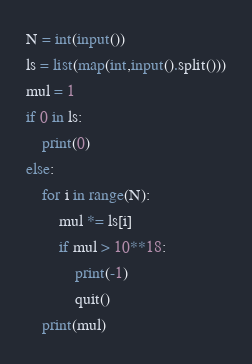Convert code to text. <code><loc_0><loc_0><loc_500><loc_500><_Python_>N = int(input())
ls = list(map(int,input().split()))
mul = 1
if 0 in ls:
    print(0)
else:
    for i in range(N):
        mul *= ls[i]
        if mul > 10**18:
            print(-1)
            quit()
    print(mul)</code> 